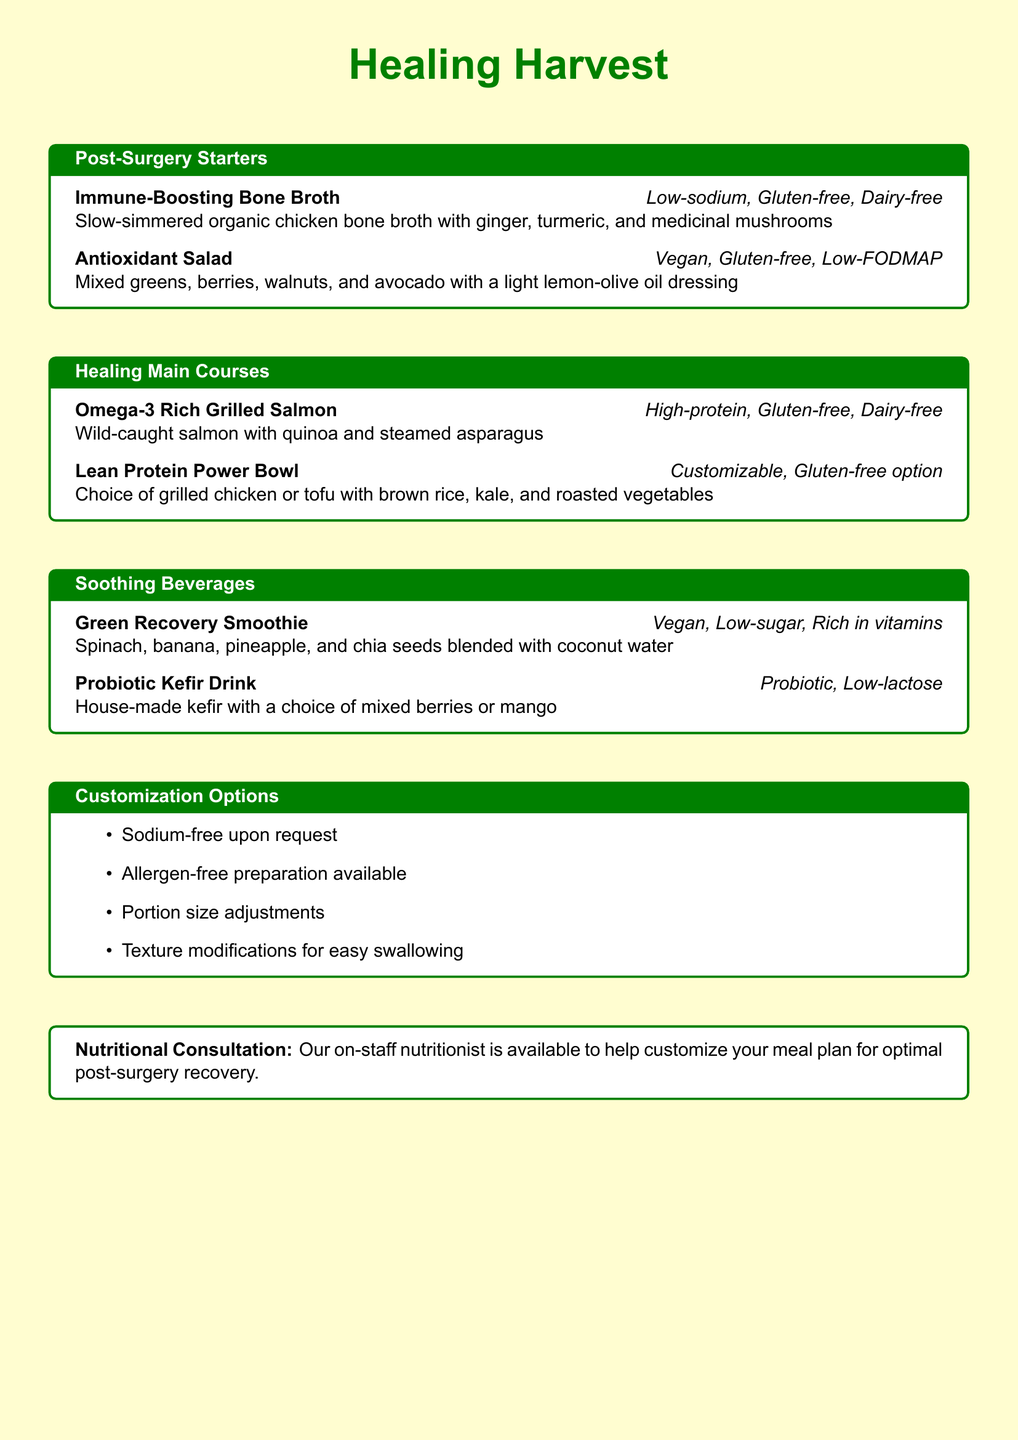What is the name of the restaurant? The restaurant is called 'Healing Harvest', as stated at the beginning of the document.
Answer: Healing Harvest What type of broth is offered as a starter? The starter includes 'Immune-Boosting Bone Broth', which is low-sodium, gluten-free, and dairy-free.
Answer: Immune-Boosting Bone Broth What main course is rich in Omega-3? The main course rich in Omega-3 is 'Grilled Salmon', highlighted in the healing main courses section.
Answer: Grilled Salmon How many customization options are listed? The document lists four customization options for meals, which include sodium-free preparation and allergen-free preparation, among others.
Answer: Four Is the 'Lean Protein Power Bowl' customizable? The description indicates that the 'Lean Protein Power Bowl' includes a customizable option.
Answer: Yes What beverage contains probiotics? The document mentions 'Probiotic Kefir Drink' as a beverage option that contains probiotics.
Answer: Probiotic Kefir Drink Which salad is vegan and gluten-free? The 'Antioxidant Salad' is specified as vegan and gluten-free in the post-surgery starters section.
Answer: Antioxidant Salad What can be adjusted upon request? The document states that portion size adjustments can be made upon request for meals.
Answer: Portion size adjustments Who is available for nutritional consultation? The document indicates that an on-staff nutritionist is available for meal plan customization.
Answer: Nutritionist 